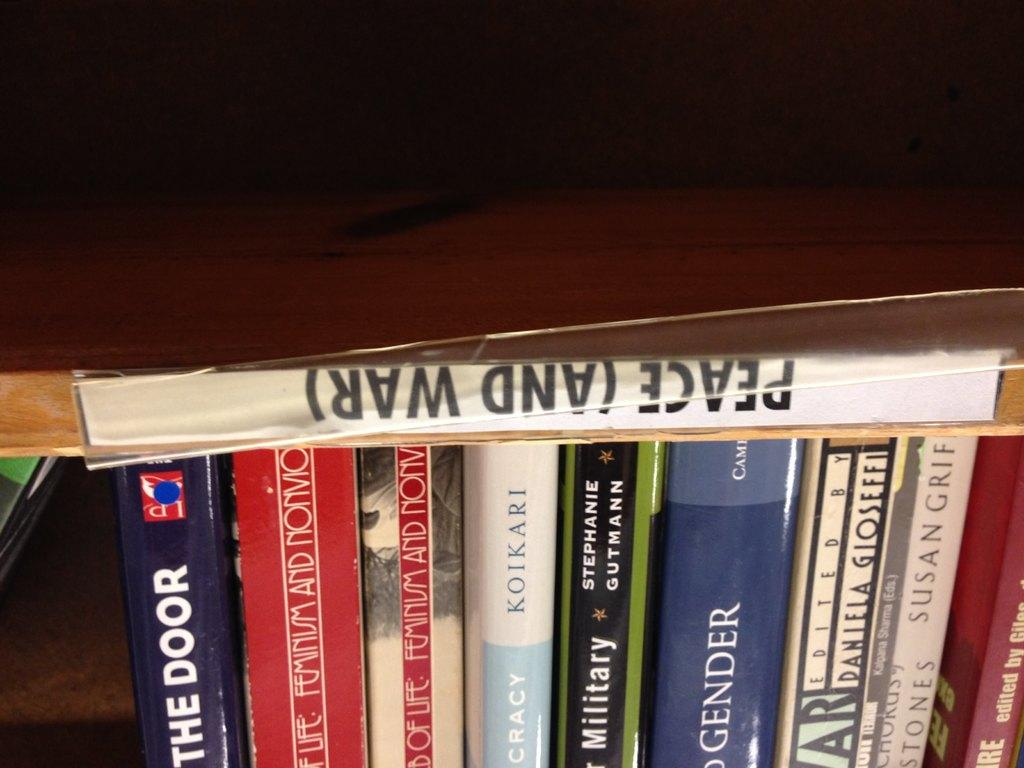Provide a one-sentence caption for the provided image. A group of books that are together under the section called Peace (and war). 